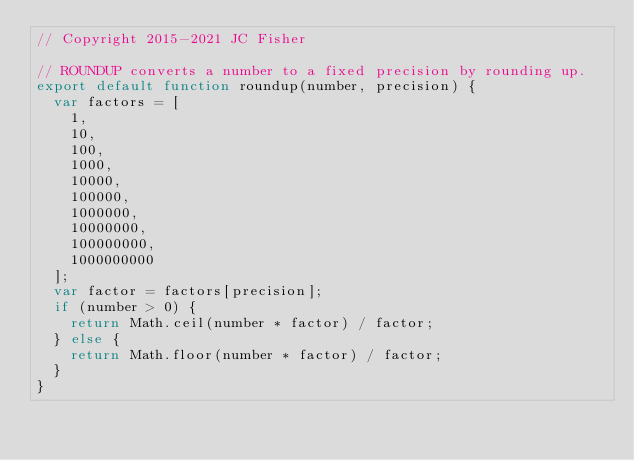Convert code to text. <code><loc_0><loc_0><loc_500><loc_500><_JavaScript_>// Copyright 2015-2021 JC Fisher

// ROUNDUP converts a number to a fixed precision by rounding up.
export default function roundup(number, precision) {
  var factors = [
    1,
    10,
    100,
    1000,
    10000,
    100000,
    1000000,
    10000000,
    100000000,
    1000000000
  ];
  var factor = factors[precision];
  if (number > 0) {
    return Math.ceil(number * factor) / factor;
  } else {
    return Math.floor(number * factor) / factor;
  }
}
</code> 